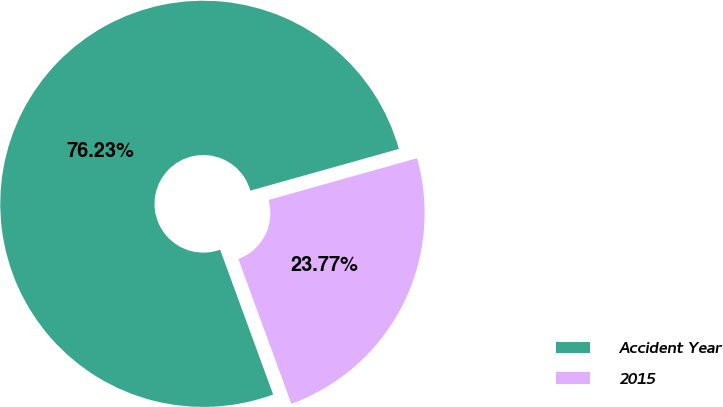Convert chart to OTSL. <chart><loc_0><loc_0><loc_500><loc_500><pie_chart><fcel>Accident Year<fcel>2015<nl><fcel>76.23%<fcel>23.77%<nl></chart> 